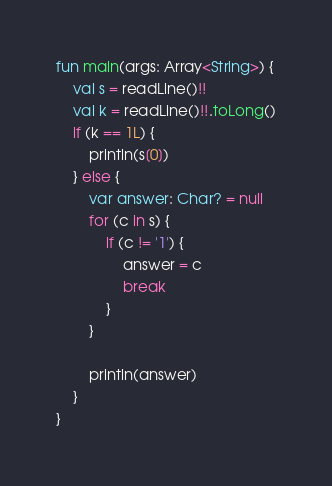<code> <loc_0><loc_0><loc_500><loc_500><_Kotlin_>fun main(args: Array<String>) {
    val s = readLine()!!
    val k = readLine()!!.toLong()
    if (k == 1L) {
        println(s[0])
    } else {
        var answer: Char? = null
        for (c in s) {
            if (c != '1') {
                answer = c
                break
            }
        }

        println(answer)
    }
}</code> 